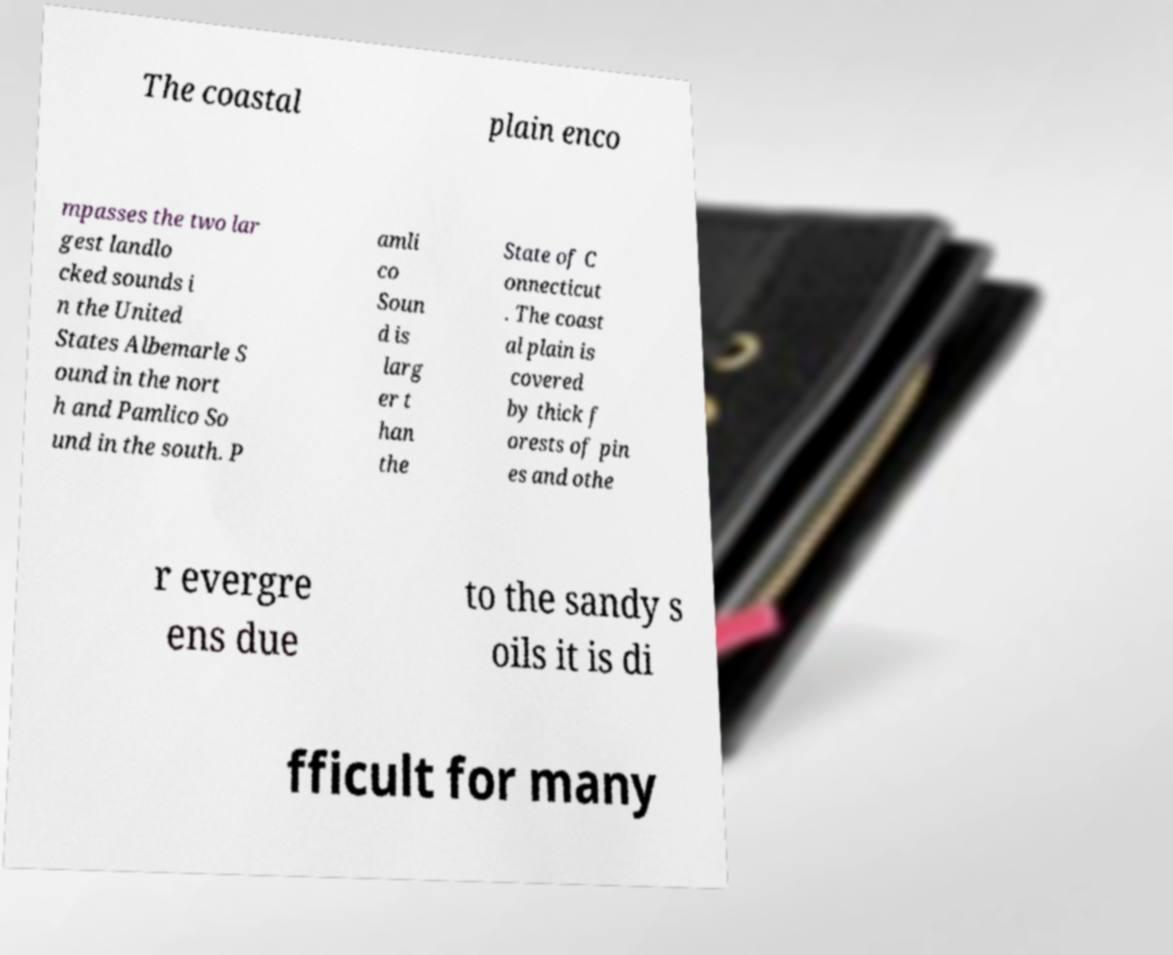Please read and relay the text visible in this image. What does it say? The coastal plain enco mpasses the two lar gest landlo cked sounds i n the United States Albemarle S ound in the nort h and Pamlico So und in the south. P amli co Soun d is larg er t han the State of C onnecticut . The coast al plain is covered by thick f orests of pin es and othe r evergre ens due to the sandy s oils it is di fficult for many 